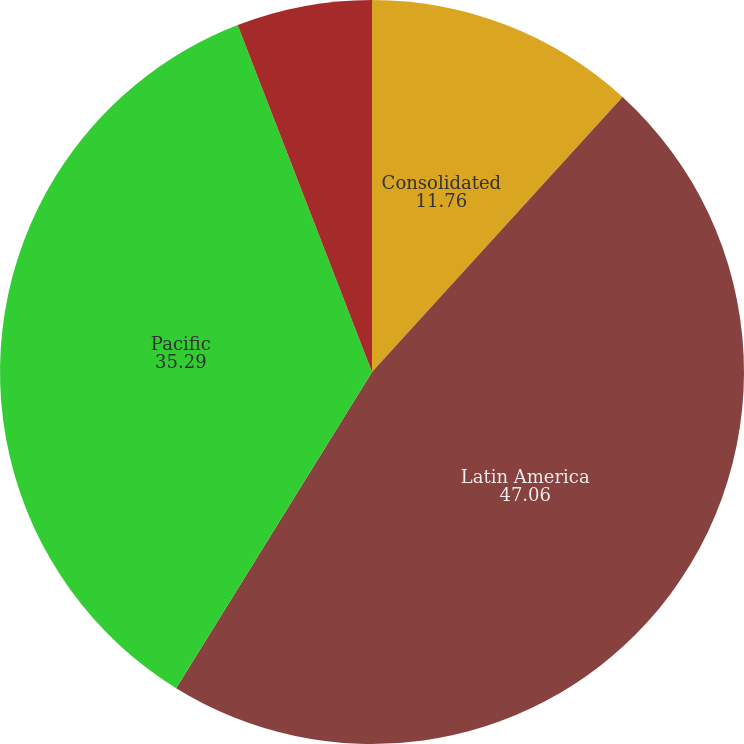<chart> <loc_0><loc_0><loc_500><loc_500><pie_chart><fcel>Consolidated<fcel>Latin America<fcel>Pacific<fcel>Bottling Investments<nl><fcel>11.76%<fcel>47.06%<fcel>35.29%<fcel>5.88%<nl></chart> 